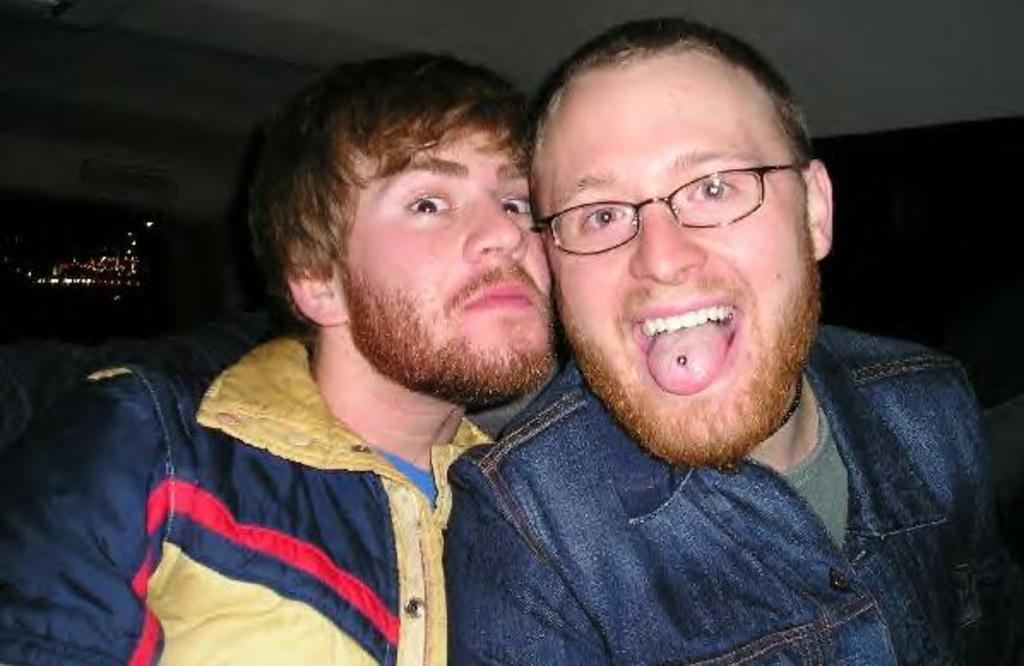How many people are in the image? There are two men in the image. What are the men wearing in the image? The men are wearing jackets. Where are the men located in the image? The men are sitting inside a car. What song is the car singing in the image? Cars do not sing songs; they are inanimate objects. The men may be listening to a song, but it cannot be determined from the image. 